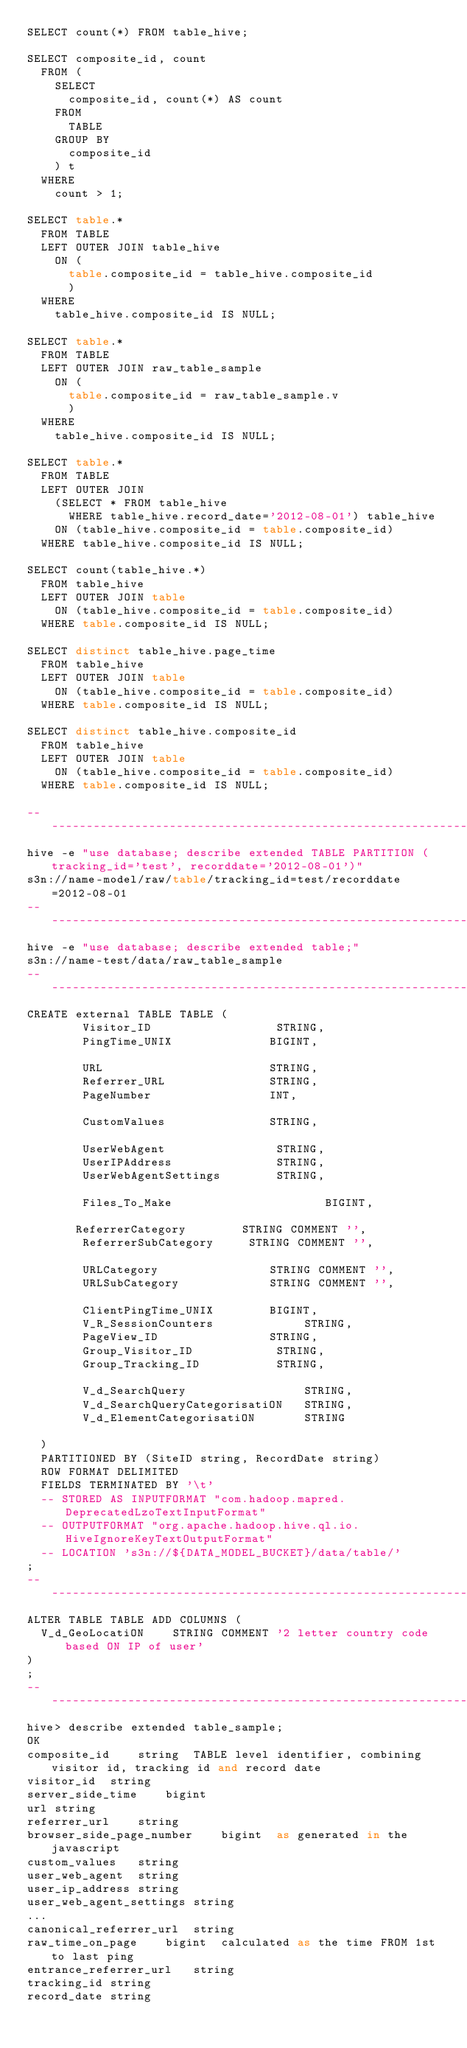<code> <loc_0><loc_0><loc_500><loc_500><_SQL_>SELECT count(*) FROM table_hive;

SELECT composite_id, count 
  FROM (
    SELECT 
      composite_id, count(*) AS count 
    FROM 
      TABLE 
    GROUP BY 
      composite_id
    ) t 
  WHERE 
    count > 1;   

SELECT table.*
  FROM TABLE 
  LEFT OUTER JOIN table_hive 
    ON (
      table.composite_id = table_hive.composite_id
      )
  WHERE 
    table_hive.composite_id IS NULL;

SELECT table.*
  FROM TABLE 
  LEFT OUTER JOIN raw_table_sample 
    ON (
      table.composite_id = raw_table_sample.v
      )
  WHERE 
    table_hive.composite_id IS NULL;

SELECT table.*
  FROM TABLE 
  LEFT OUTER JOIN 
    (SELECT * FROM table_hive 
      WHERE table_hive.record_date='2012-08-01') table_hive
    ON (table_hive.composite_id = table.composite_id)
  WHERE table_hive.composite_id IS NULL;

SELECT count(table_hive.*)
  FROM table_hive 
  LEFT OUTER JOIN table
    ON (table_hive.composite_id = table.composite_id)
  WHERE table.composite_id IS NULL;

SELECT distinct table_hive.page_time
  FROM table_hive 
  LEFT OUTER JOIN table
    ON (table_hive.composite_id = table.composite_id)
  WHERE table.composite_id IS NULL;

SELECT distinct table_hive.composite_id
  FROM table_hive 
  LEFT OUTER JOIN table
    ON (table_hive.composite_id = table.composite_id)
  WHERE table.composite_id IS NULL;

-- -----------------------------------------------------------------------------
hive -e "use database; describe extended TABLE PARTITION (tracking_id='test', recorddate='2012-08-01')"
s3n://name-model/raw/table/tracking_id=test/recorddate=2012-08-01
-- -----------------------------------------------------------------------------
hive -e "use database; describe extended table;"
s3n://name-test/data/raw_table_sample
-- -----------------------------------------------------------------------------
CREATE external TABLE TABLE (
        Visitor_ID                  STRING,
        PingTime_UNIX              BIGINT,

        URL                        STRING,
        Referrer_URL               STRING,
        PageNumber                 INT,
        
        CustomValues               STRING,
        
        UserWebAgent                STRING,
        UserIPAddress               STRING,
        UserWebAgentSettings        STRING,
        
        Files_To_Make                      BIGINT,

       ReferrerCategory        STRING COMMENT '',
        ReferrerSubCategory     STRING COMMENT '',

        URLCategory                STRING COMMENT '',
        URLSubCategory             STRING COMMENT '',
        
        ClientPingTime_UNIX        BIGINT,
        V_R_SessionCounters             STRING,
        PageView_ID                STRING,
        Group_Visitor_ID            STRING,
        Group_Tracking_ID           STRING,
        
        V_d_SearchQuery                 STRING,
        V_d_SearchQueryCategorisatiON   STRING,
        V_d_ElementCategorisatiON       STRING
        
  )
  PARTITIONED BY (SiteID string, RecordDate string)
  ROW FORMAT DELIMITED
  FIELDS TERMINATED BY '\t'
  -- STORED AS INPUTFORMAT "com.hadoop.mapred.DeprecatedLzoTextInputFormat"
  -- OUTPUTFORMAT "org.apache.hadoop.hive.ql.io.HiveIgnoreKeyTextOutputFormat"
  -- LOCATION 's3n://${DATA_MODEL_BUCKET}/data/table/'
;
-- -----------------------------------------------------------------------------
ALTER TABLE TABLE ADD COLUMNS (
  V_d_GeoLocatiON    STRING COMMENT '2 letter country code based ON IP of user'
)
;
-- ----------------------------------------------------------------------------
hive> describe extended table_sample;
OK
composite_id    string  TABLE level identifier, combining visitor id, tracking id and record date
visitor_id  string  
server_side_time    bigint  
url string  
referrer_url    string  
browser_side_page_number    bigint  as generated in the javascript
custom_values   string  
user_web_agent  string  
user_ip_address string  
user_web_agent_settings string  
...
canonical_referrer_url  string  
raw_time_on_page    bigint  calculated as the time FROM 1st to last ping
entrance_referrer_url   string  
tracking_id string  
record_date string  
         </code> 